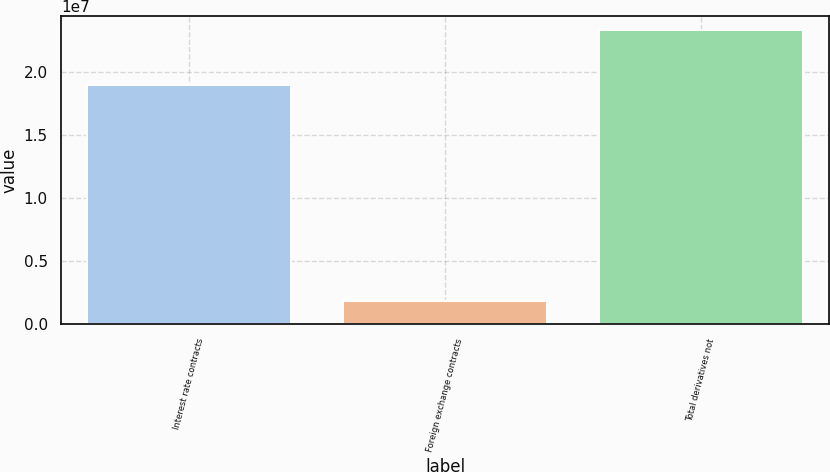Convert chart to OTSL. <chart><loc_0><loc_0><loc_500><loc_500><bar_chart><fcel>Interest rate contracts<fcel>Foreign exchange contracts<fcel>Total derivatives not<nl><fcel>1.89172e+07<fcel>1.83785e+06<fcel>2.32598e+07<nl></chart> 